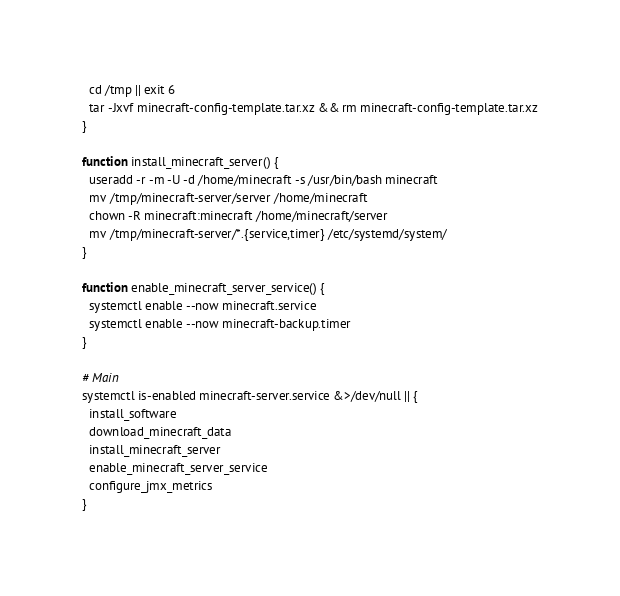<code> <loc_0><loc_0><loc_500><loc_500><_Bash_>  cd /tmp || exit 6
  tar -Jxvf minecraft-config-template.tar.xz && rm minecraft-config-template.tar.xz
}

function install_minecraft_server() {
  useradd -r -m -U -d /home/minecraft -s /usr/bin/bash minecraft
  mv /tmp/minecraft-server/server /home/minecraft
  chown -R minecraft:minecraft /home/minecraft/server
  mv /tmp/minecraft-server/*.{service,timer} /etc/systemd/system/
}

function enable_minecraft_server_service() {
  systemctl enable --now minecraft.service
  systemctl enable --now minecraft-backup.timer
}

# Main
systemctl is-enabled minecraft-server.service &>/dev/null || {
  install_software
  download_minecraft_data
  install_minecraft_server
  enable_minecraft_server_service
  configure_jmx_metrics
}
</code> 